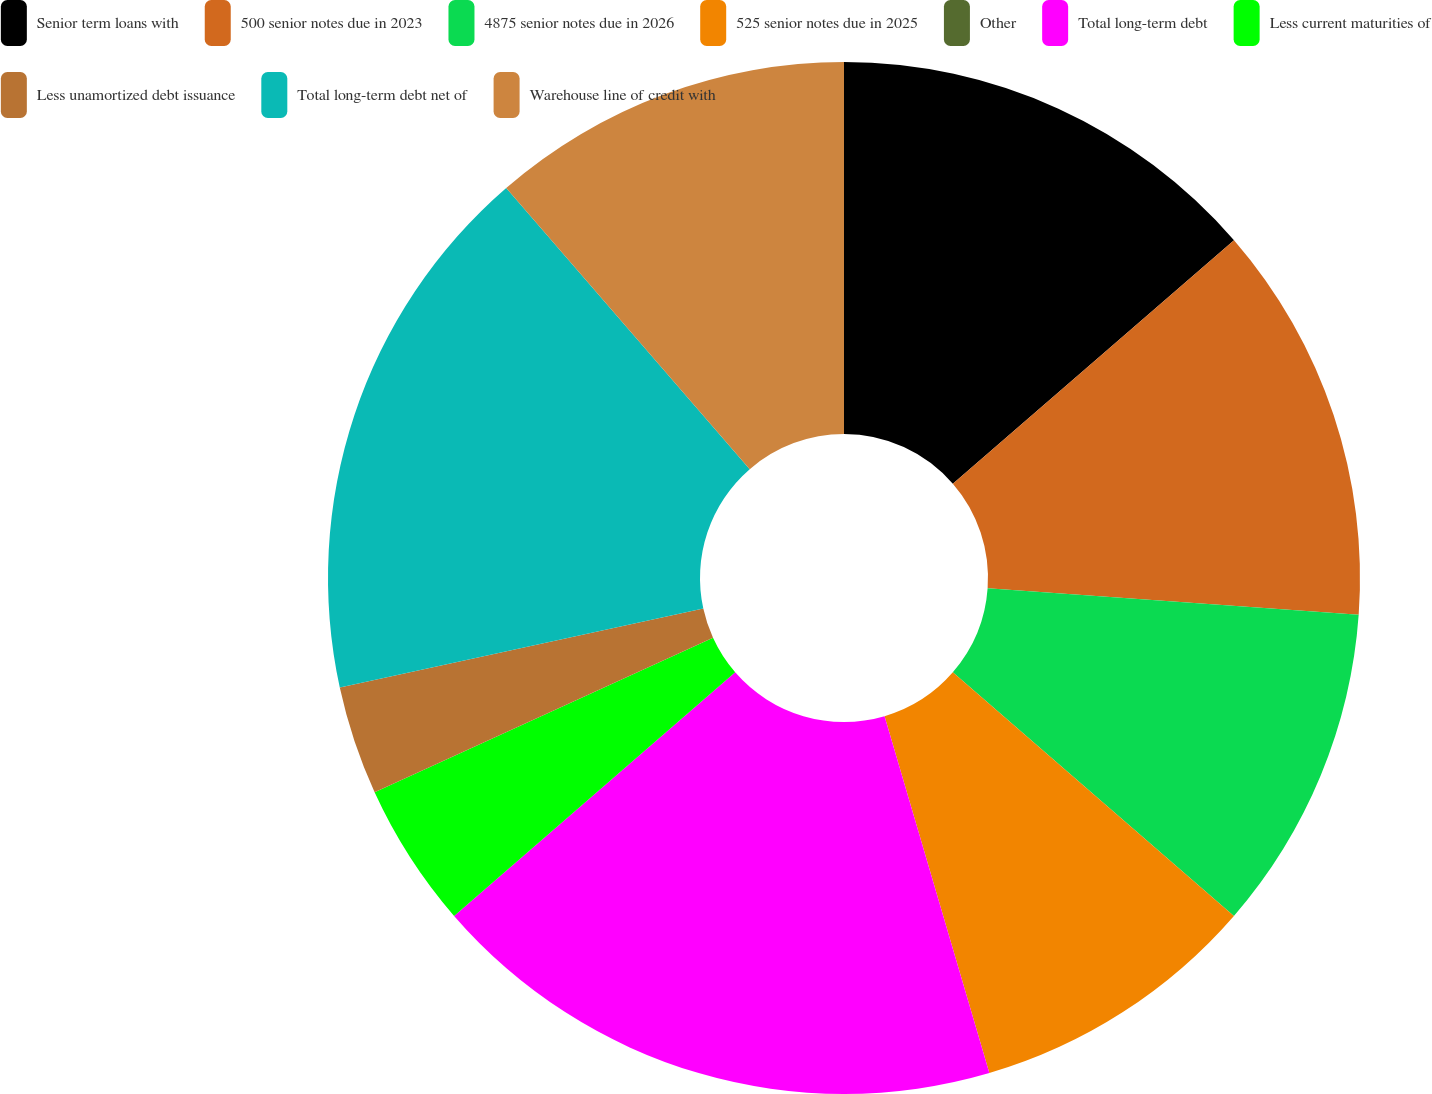Convert chart. <chart><loc_0><loc_0><loc_500><loc_500><pie_chart><fcel>Senior term loans with<fcel>500 senior notes due in 2023<fcel>4875 senior notes due in 2026<fcel>525 senior notes due in 2025<fcel>Other<fcel>Total long-term debt<fcel>Less current maturities of<fcel>Less unamortized debt issuance<fcel>Total long-term debt net of<fcel>Warehouse line of credit with<nl><fcel>13.64%<fcel>12.5%<fcel>10.23%<fcel>9.09%<fcel>0.0%<fcel>18.18%<fcel>4.55%<fcel>3.41%<fcel>17.05%<fcel>11.36%<nl></chart> 